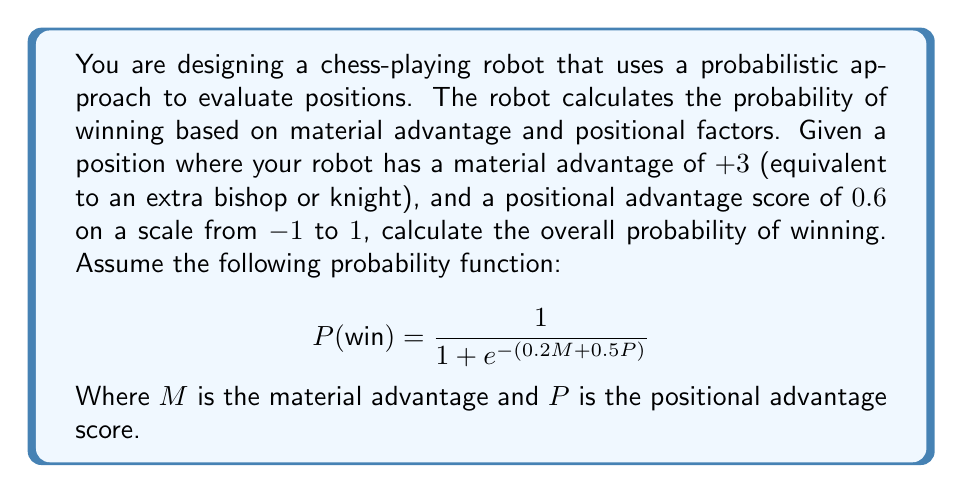What is the answer to this math problem? To solve this problem, we need to follow these steps:

1. Identify the given values:
   - Material advantage (M) = +3
   - Positional advantage score (P) = 0.6

2. Substitute these values into the given probability function:

   $$P(\text{win}) = \frac{1}{1 + e^{-(0.2M + 0.5P)}}$$

3. Calculate the exponent:
   $0.2M + 0.5P = 0.2(3) + 0.5(0.6)$
   $= 0.6 + 0.3$
   $= 0.9$

4. Substitute this value into the equation:

   $$P(\text{win}) = \frac{1}{1 + e^{-0.9}}$$

5. Calculate $e^{-0.9}$:
   $e^{-0.9} \approx 0.4066$

6. Complete the calculation:

   $$P(\text{win}) = \frac{1}{1 + 0.4066} = \frac{1}{1.4066} \approx 0.7109$$

7. Convert to a percentage:
   0.7109 * 100% ≈ 71.09%

Therefore, given the material advantage of +3 and a positional advantage score of 0.6, the robot calculates approximately a 71.09% probability of winning the game.
Answer: 71.09% 